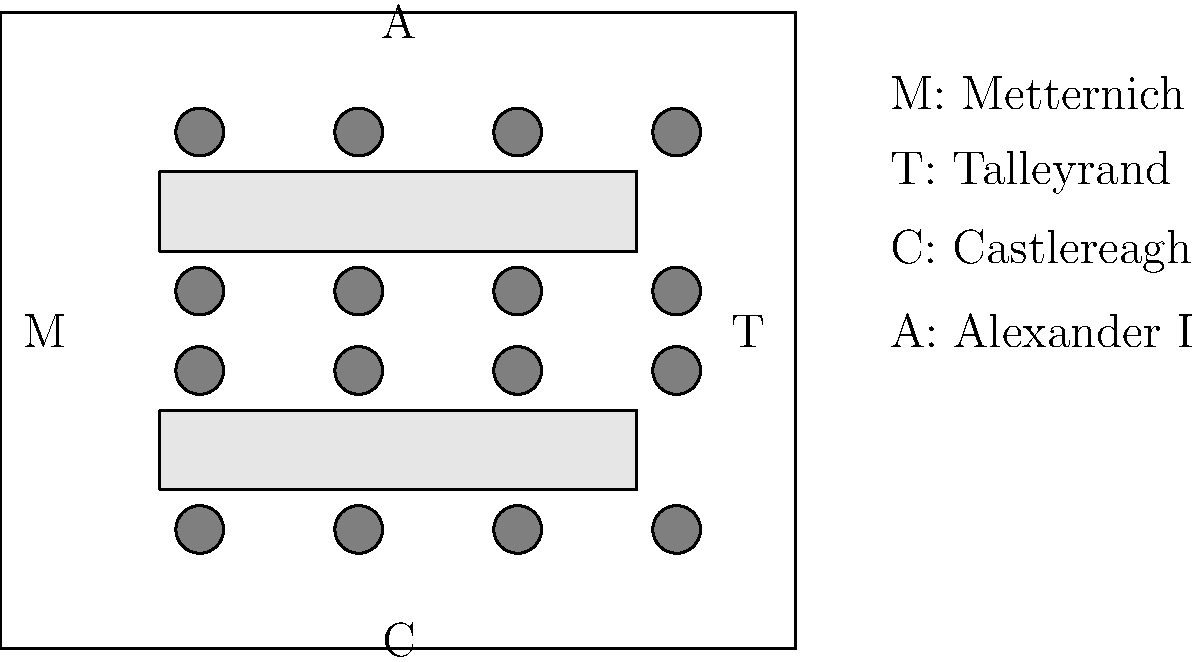Based on the floor plan of the main negotiation room during the Congress of Vienna (1814-1815), analyze the seating arrangement and positions of key figures. How might this layout have influenced the dynamics of the negotiations, particularly considering the positions of Metternich (M) and Talleyrand (T)? 1. Room layout: The diagram shows a rectangular room with two long tables in the center.

2. Seating arrangement: 
   - Each table has 8 chairs, 4 on each side.
   - Key figures are positioned at the edges of the room:
     M (Metternich) on the left
     T (Talleyrand) on the right
     C (Castlereagh) at the bottom
     A (Alexander I) at the top

3. Metternich's position (M):
   - Located on the left side of the room
   - This central position allowed him to oversee both tables
   - As the host and representative of Austria, this position gave him a commanding presence

4. Talleyrand's position (T):
   - Located on the right side of the room, opposite Metternich
   - This position allowed him to face Metternich directly
   - As France's representative, this placement put him on equal footing with Metternich

5. Influence on negotiations:
   - The face-to-face positioning of Metternich and Talleyrand suggests a balance of power
   - Their positions at the sides allowed them to address all attendees easily
   - The layout encouraged direct communication between these two key figures
   - The placement of Castlereagh (C) and Alexander I (A) at the ends of the room might have given them less prominent roles in discussions

6. Overall dynamics:
   - The symmetrical layout suggests an attempt at creating a balanced negotiation environment
   - The positioning of key figures around the periphery might have allowed for private conversations during breaks
   - The central tables likely facilitated group discussions and negotiations
Answer: The layout positioned Metternich and Talleyrand as central, opposing figures, likely facilitating direct negotiations and balancing power between Austria and France. 